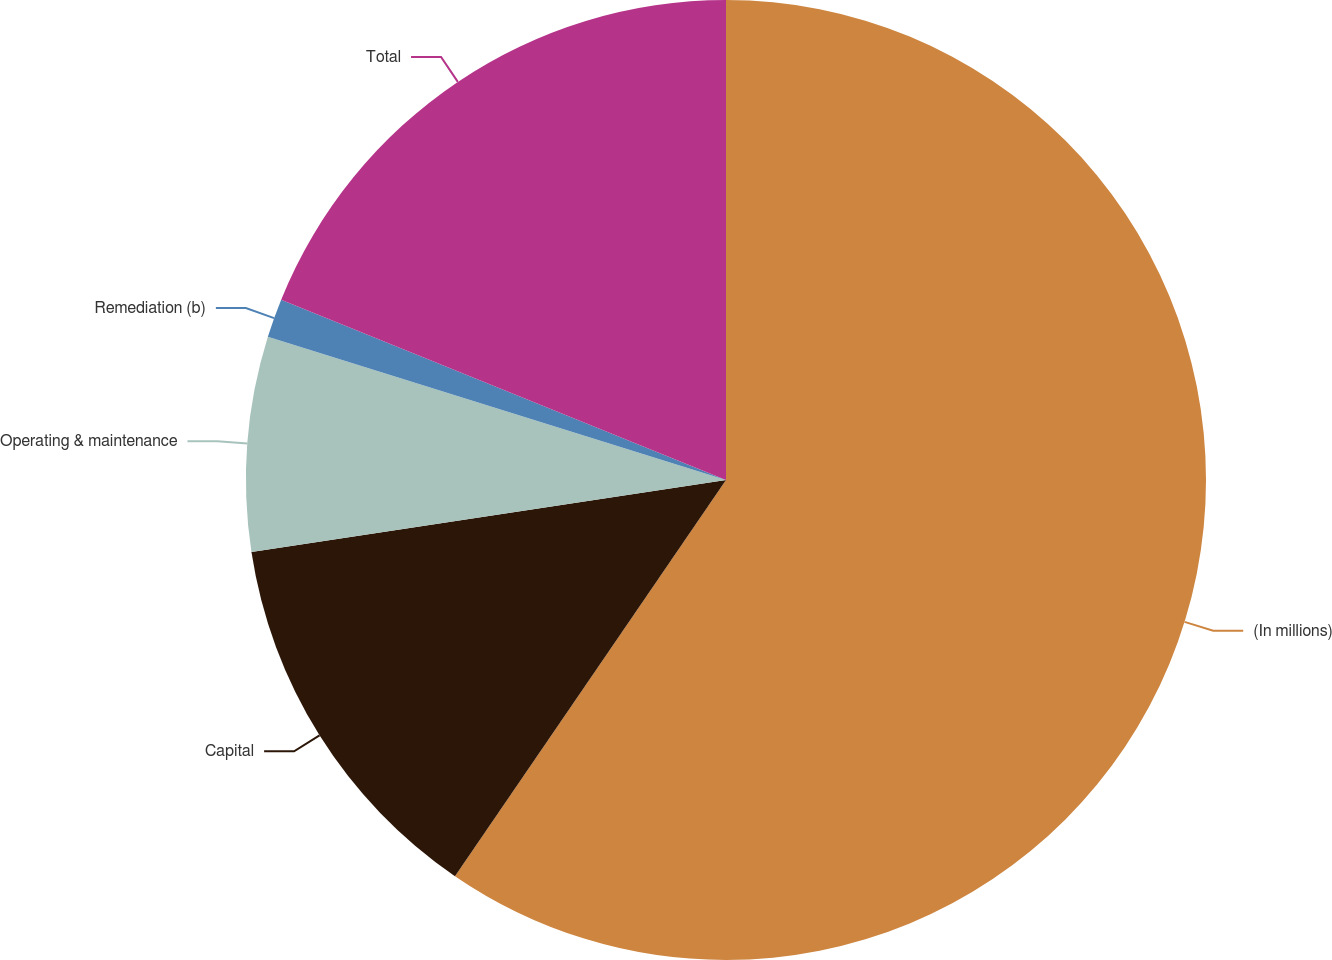Convert chart to OTSL. <chart><loc_0><loc_0><loc_500><loc_500><pie_chart><fcel>(In millions)<fcel>Capital<fcel>Operating & maintenance<fcel>Remediation (b)<fcel>Total<nl><fcel>59.55%<fcel>13.05%<fcel>7.22%<fcel>1.31%<fcel>18.87%<nl></chart> 